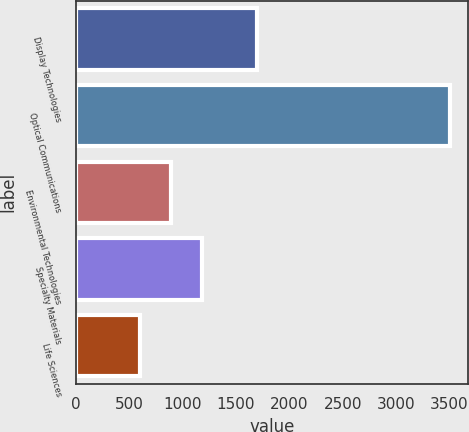Convert chart to OTSL. <chart><loc_0><loc_0><loc_500><loc_500><bar_chart><fcel>Display Technologies<fcel>Optical Communications<fcel>Environmental Technologies<fcel>Specialty Materials<fcel>Life Sciences<nl><fcel>1700<fcel>3500<fcel>890<fcel>1180<fcel>600<nl></chart> 